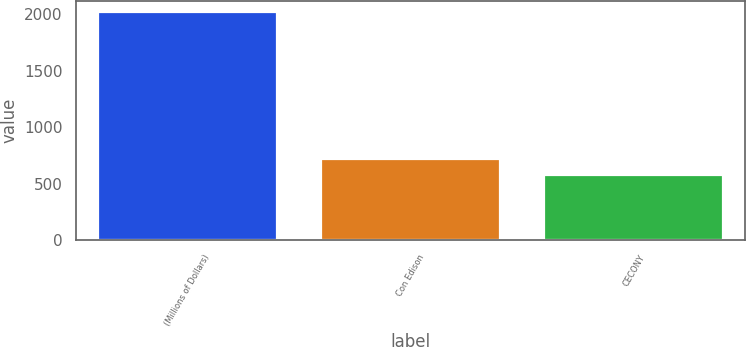Convert chart. <chart><loc_0><loc_0><loc_500><loc_500><bar_chart><fcel>(Millions of Dollars)<fcel>Con Edison<fcel>CECONY<nl><fcel>2016<fcel>716.4<fcel>572<nl></chart> 